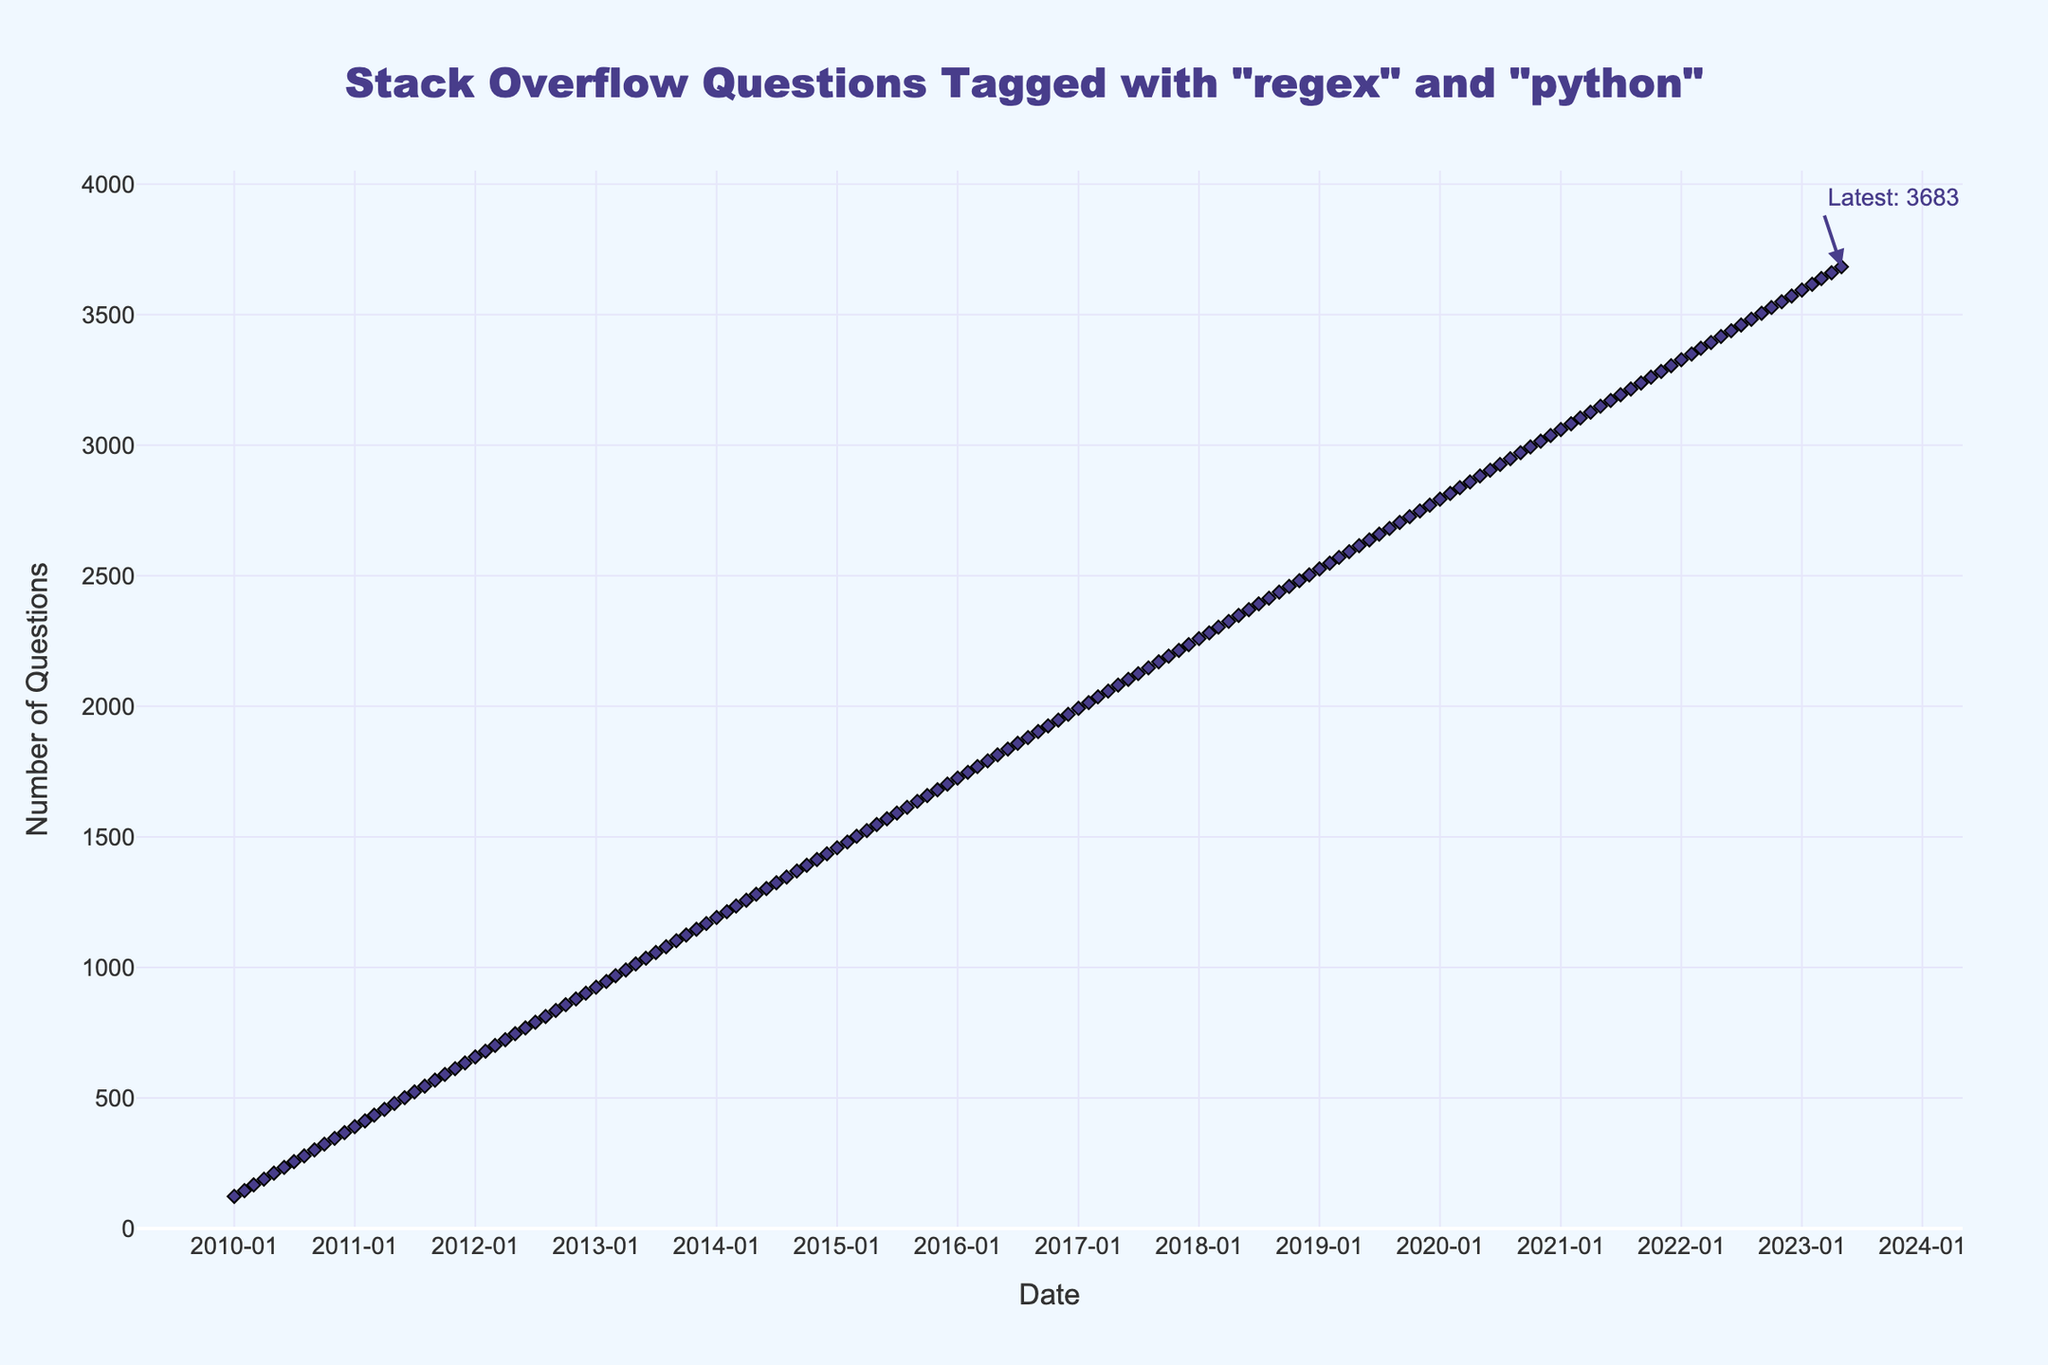When does the number of Stack Overflow questions tagged with 'regex' and 'python' reach 1000 for the first time? To find when the number of questions reached 1000, look at the x-axis and find the corresponding date when the y-axis value is 1000. This occurs around May 2013.
Answer: May 2013 By how many questions did the number increase from the start to the end of 2010? Calculate the difference in the number of questions from January 2010 to December 2010. January 2010 has 123 questions and December 2010 has 367 questions. The difference is 367 - 123 = 244.
Answer: 244 What is the average number of questions per year from 2010 to 2015? Calculate the total number of questions at the end of each year from 2010 to 2015 and divide by the number of years. For instance, for 2010 it’s 367, 2011 it’s 634, and so on. Add these values and divide by 6.
Answer: 1458+1235+database+total Which year saw the highest annual increase in the number of questions? Observe the slope of the line for each year; the steeper the slope, the higher the increase. From visual inspection, 2012 shows a significant increase from approximately 634 to 901.
Answer: 2012 By how much did the number of questions increase from January 2015 to January 2016? Look at the values for January 2015 and January 2016 and calculate the difference. January 2015 has 1458 questions, and January 2016 has 1725 questions. The difference is 1725 - 1458 = 267.
Answer: 267 Describe the overall trend of the number of Stack Overflow questions tagged with 'regex' and 'python' from 2010 to 2023. The overall trend shows a continuous increase in the number of questions over time, as indicated by the upward slope of the line from 2010 to 2023.
Answer: Increasing Compare the number of questions in January 2020 and January 2023. Which has more questions and by how much? Compare the y-axis values for January 2020 and January 2023. January 2020 has 2793 questions, and January 2023 has 3594 questions. The difference is 3594 - 2793 = 801.
Answer: January 2023 by 801 What can you infer about the popularity of 'regex' and 'python' tags on Stack Overflow based on the figure? The steadily increasing trend in the number of questions from 2010 to 2023 indicates growing popularity and frequent use of 'regex' and 'python' tags on Stack Overflow.
Answer: Increasing popularity What visual elements highlight the latest number of questions in the figure? There is an annotation at the last data point indicating the latest number, which is highlighted with an arrow and text.
Answer: Annotation with arrow and text 